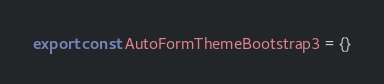Convert code to text. <code><loc_0><loc_0><loc_500><loc_500><_JavaScript_>export const AutoFormThemeBootstrap3 = {}
</code> 